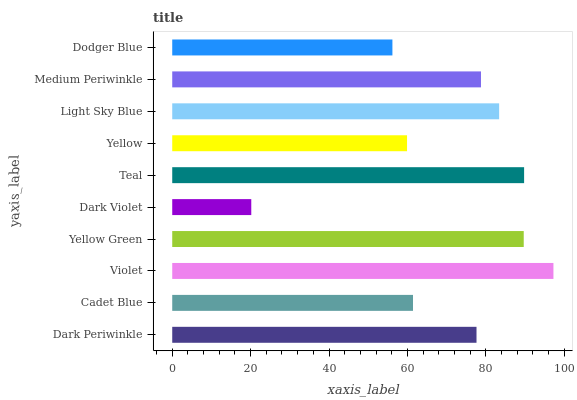Is Dark Violet the minimum?
Answer yes or no. Yes. Is Violet the maximum?
Answer yes or no. Yes. Is Cadet Blue the minimum?
Answer yes or no. No. Is Cadet Blue the maximum?
Answer yes or no. No. Is Dark Periwinkle greater than Cadet Blue?
Answer yes or no. Yes. Is Cadet Blue less than Dark Periwinkle?
Answer yes or no. Yes. Is Cadet Blue greater than Dark Periwinkle?
Answer yes or no. No. Is Dark Periwinkle less than Cadet Blue?
Answer yes or no. No. Is Medium Periwinkle the high median?
Answer yes or no. Yes. Is Dark Periwinkle the low median?
Answer yes or no. Yes. Is Dark Periwinkle the high median?
Answer yes or no. No. Is Medium Periwinkle the low median?
Answer yes or no. No. 